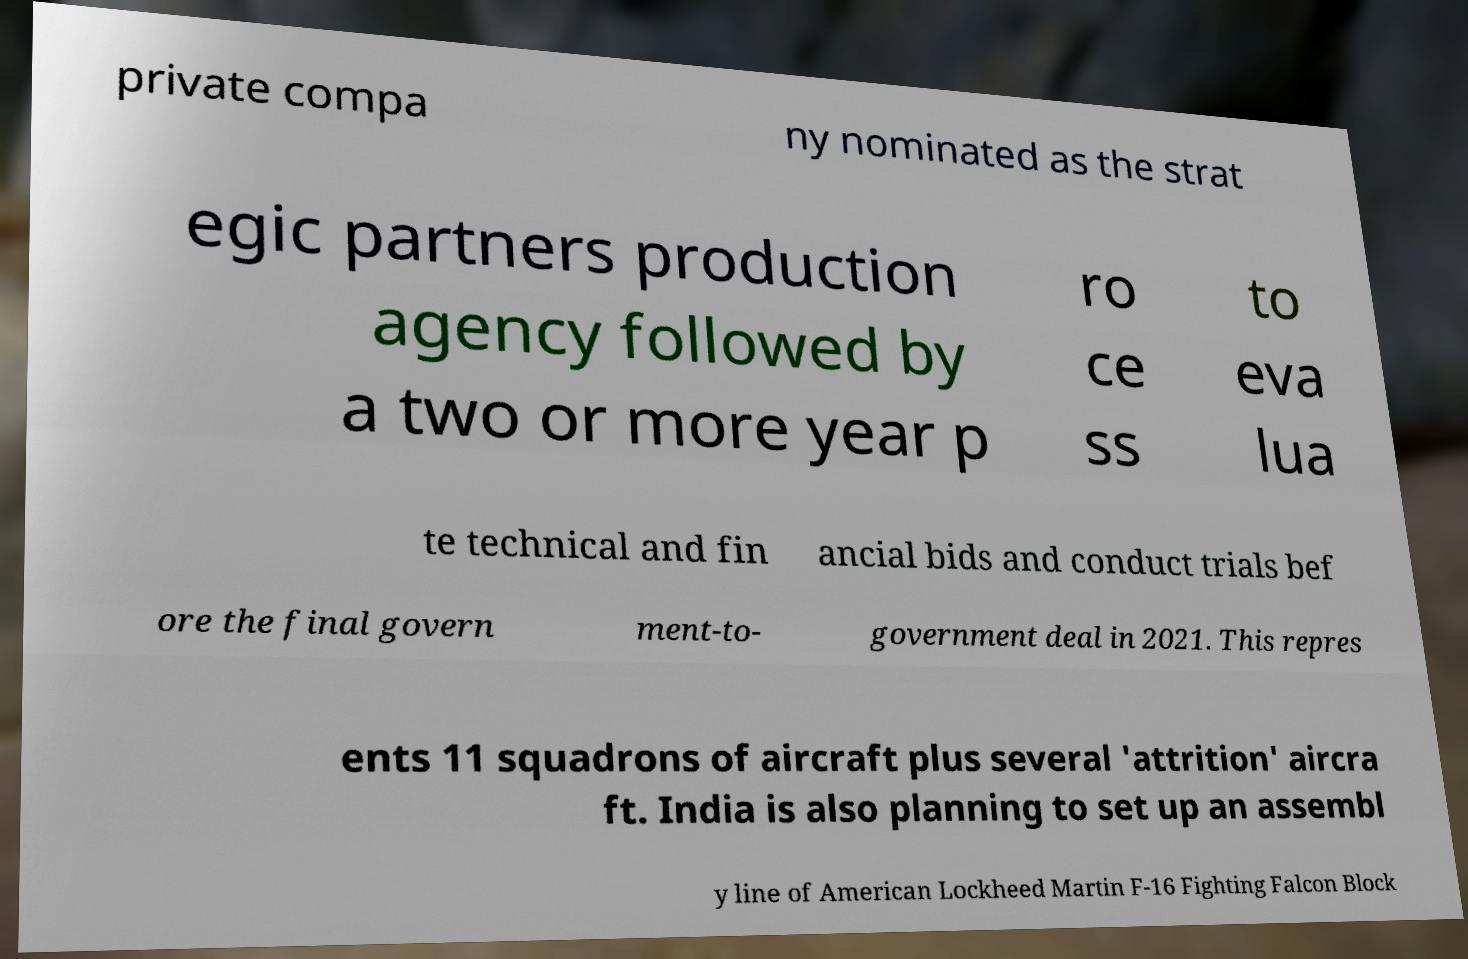I need the written content from this picture converted into text. Can you do that? private compa ny nominated as the strat egic partners production agency followed by a two or more year p ro ce ss to eva lua te technical and fin ancial bids and conduct trials bef ore the final govern ment-to- government deal in 2021. This repres ents 11 squadrons of aircraft plus several 'attrition' aircra ft. India is also planning to set up an assembl y line of American Lockheed Martin F-16 Fighting Falcon Block 